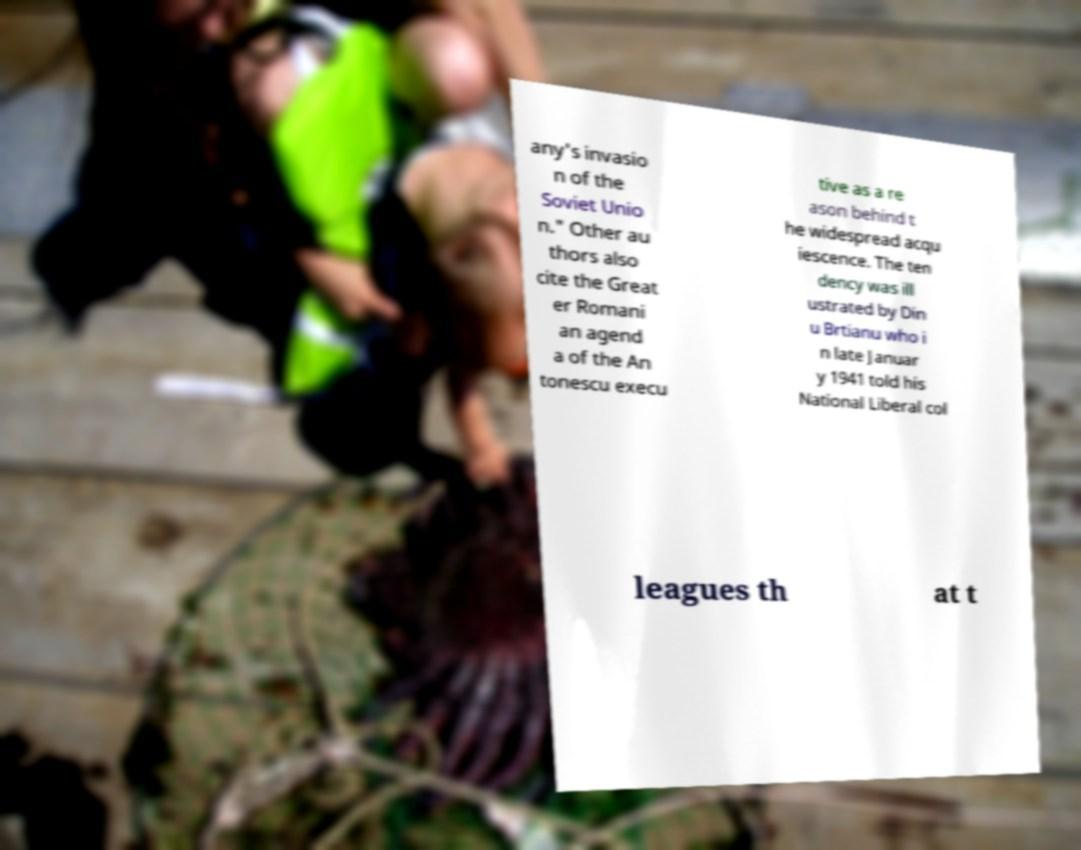For documentation purposes, I need the text within this image transcribed. Could you provide that? any's invasio n of the Soviet Unio n." Other au thors also cite the Great er Romani an agend a of the An tonescu execu tive as a re ason behind t he widespread acqu iescence. The ten dency was ill ustrated by Din u Brtianu who i n late Januar y 1941 told his National Liberal col leagues th at t 